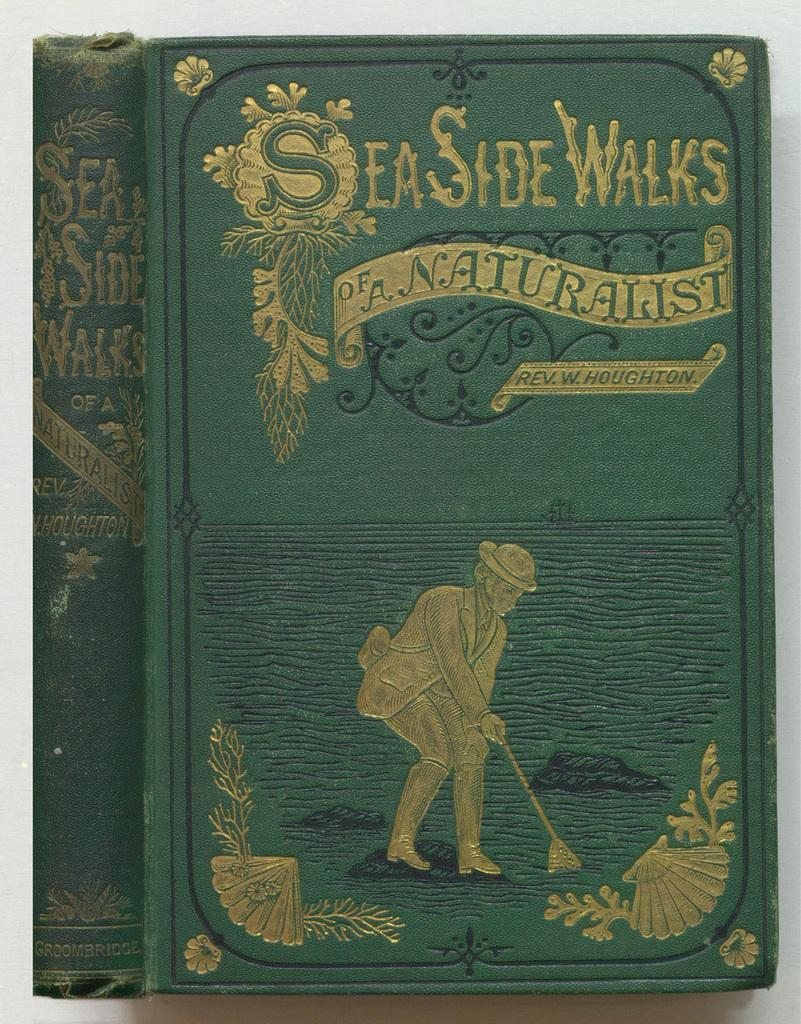<image>
Summarize the visual content of the image. An old copy of SeaSide Walks has a gold embossed cover. 